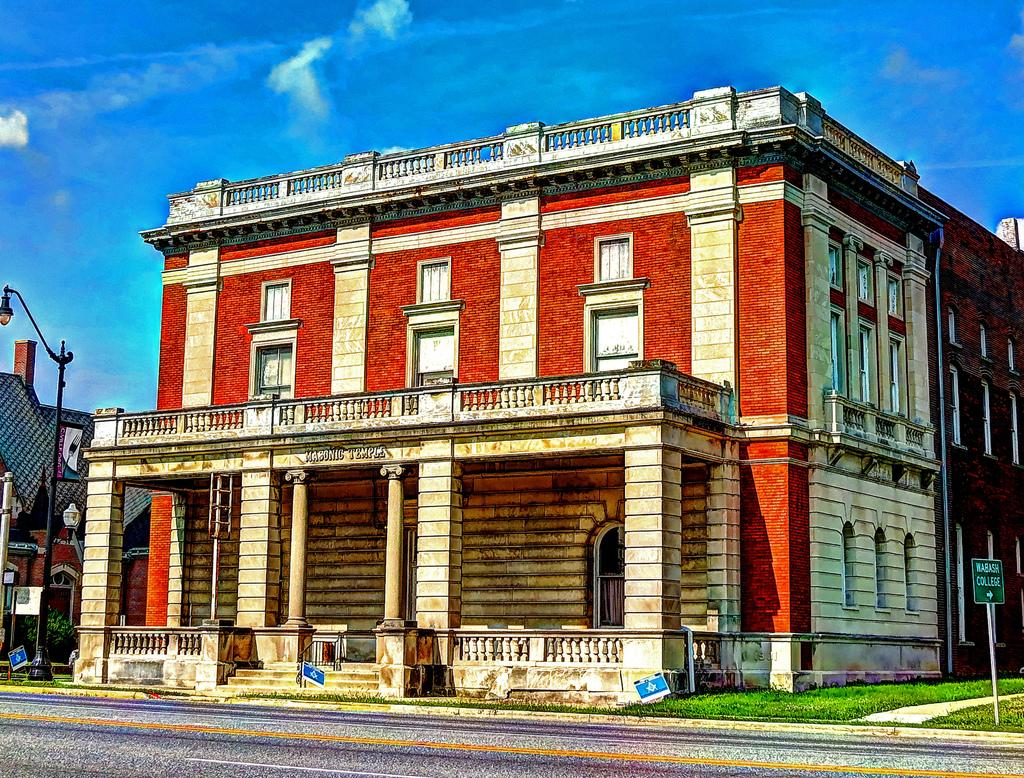What type of structures can be seen in the image? There are buildings in the image. What architectural features are present in the image? There are windows, stairs, pillars, and a light pole visible in the image. Are there any signs or indicators in the image? Yes, there are sign boards in the image. What is the color of the sky in the image? The sky is blue and white in color. What type of orange is hanging from the bridge in the image? There is no orange or bridge present in the image. What company is responsible for the construction of the buildings in the image? The provided facts do not mention any company or construction details, so it cannot be determined from the image. 